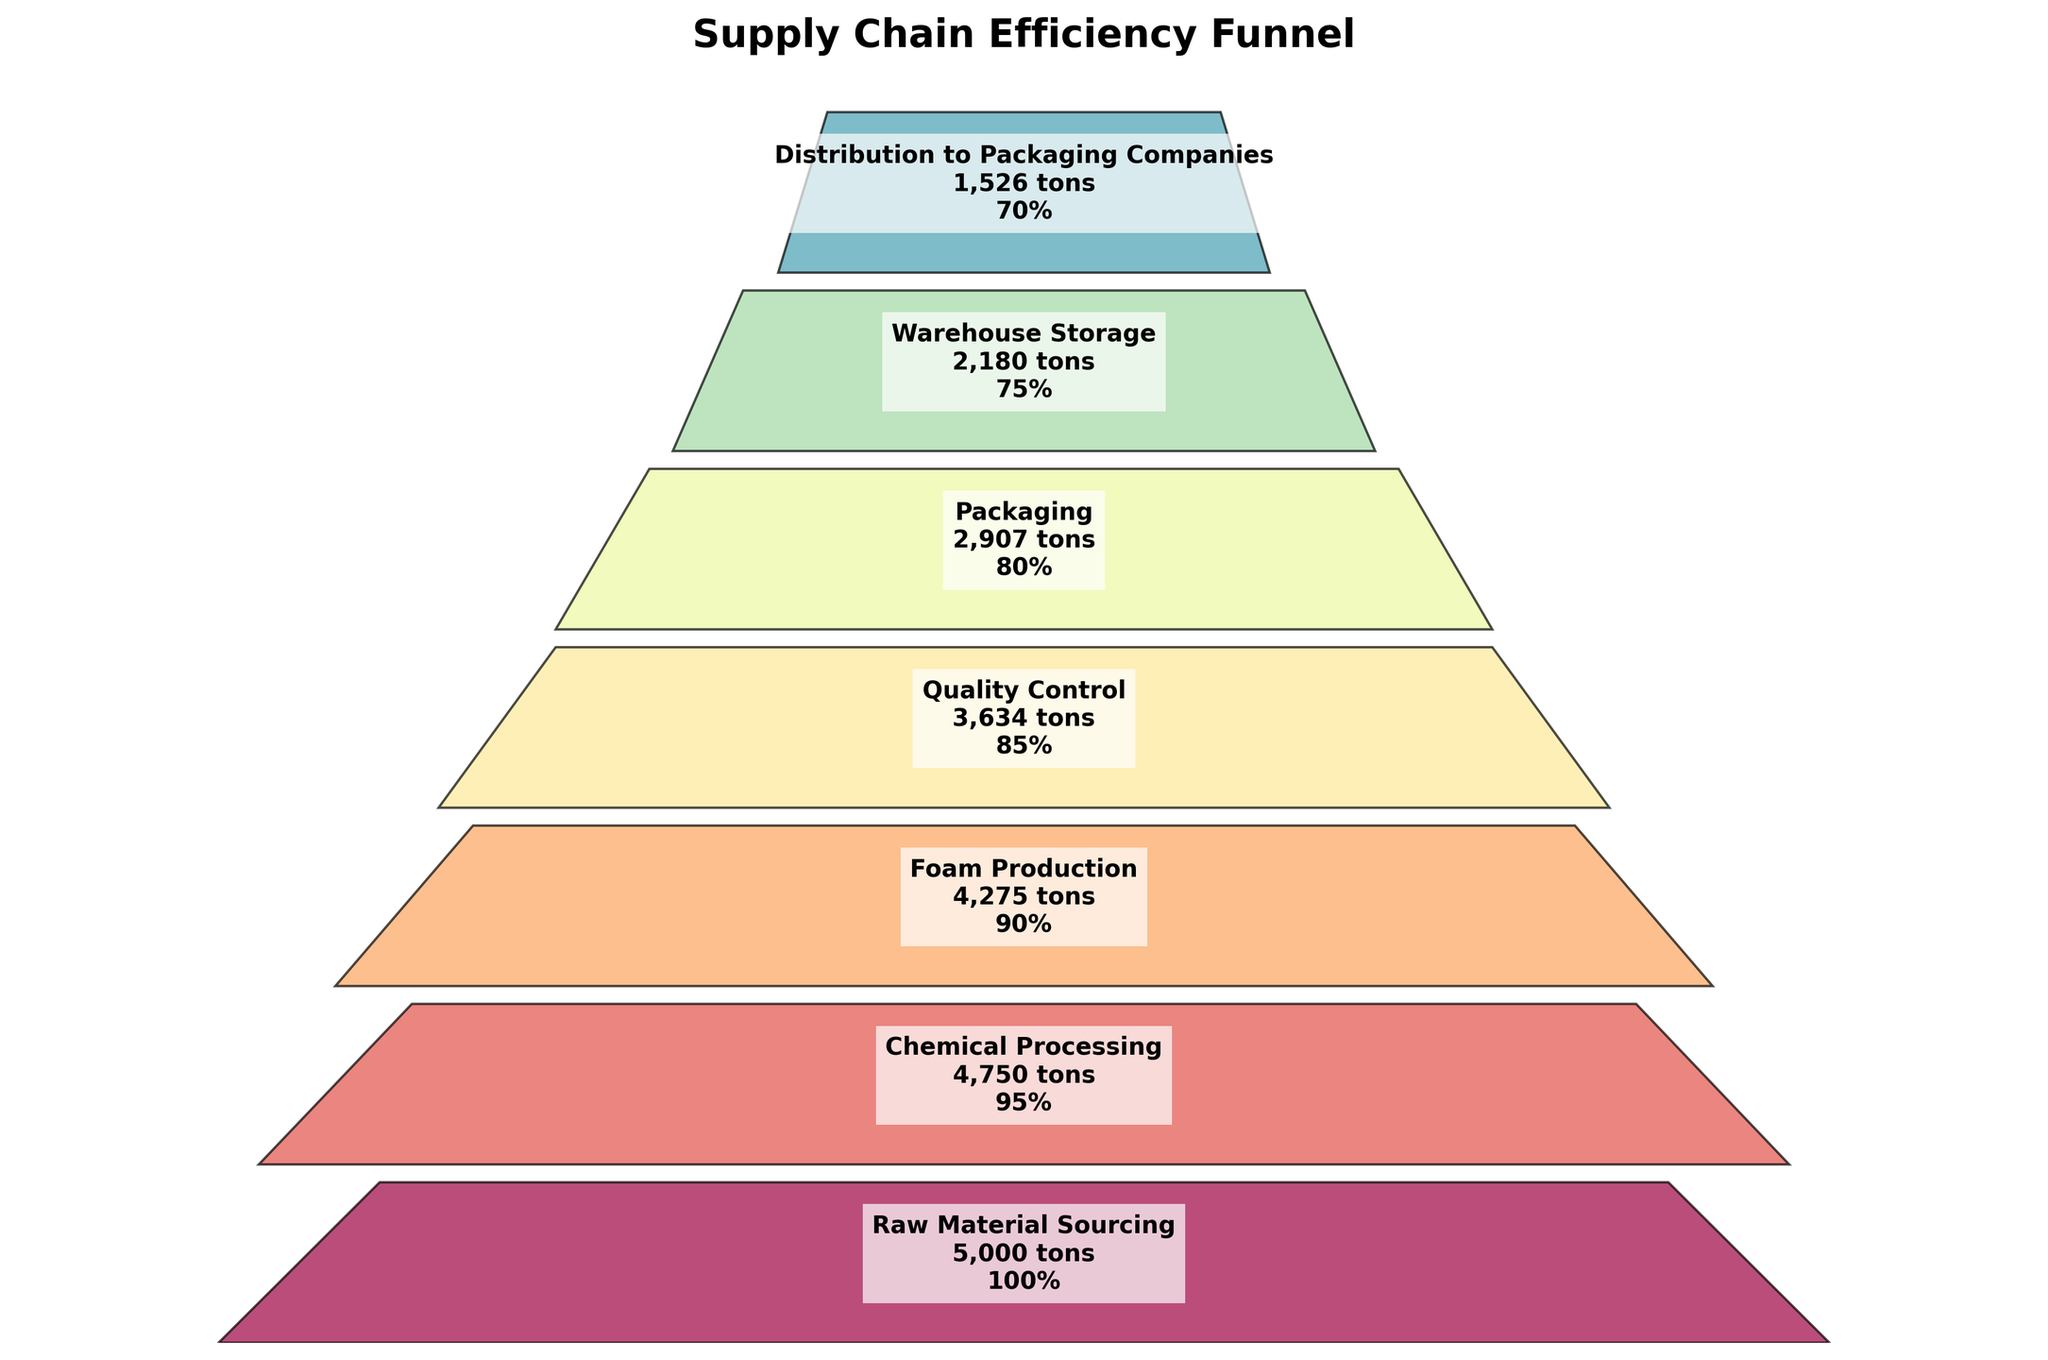How many stages are there in the supply chain? The stages are listed in the funnel chart, and each row represents a stage. Counting the rows gives the total number of stages.
Answer: 7 Which stage has the lowest volume of raw materials? By looking at the volumes listed beside each stage, the 'Distribution to Packaging Companies' stage has the lowest volume at 1526 metric tons.
Answer: Distribution to Packaging Companies What is the efficiency of the Packaging stage? The efficiency is shown next to each stage. For the Packaging stage, it is 80%.
Answer: 80% How much volume of raw materials is lost from Raw Material Sourcing to Distribution to Packaging Companies? Subtract the final volume (1526 metric tons) from the initial volume (5000 metric tons). 5000 - 1526 = 3474 metric tons.
Answer: 3474 metric tons Which stage shows the highest drop in efficiency compared to the previous stage? Compare the efficiency percentages between consecutive stages and find the largest difference. The drop from Quality Control to Packaging (85% to 80%) results in a 5% drop, which is the highest.
Answer: Quality Control to Packaging Calculate the average efficiency across all stages. Sum the efficiencies of all stages and then divide by the number of stages: (100 + 95 + 90 + 85 + 80 + 75 + 70) / 7 = 85%.
Answer: 85% Which stages lose more than 500 metric tons of raw materials compared to the previous stage? Look for stages where the difference in volume between consecutive stages is greater than 500 metric tons. Chemical Processing to Foam Production (4750 - 4275 = 475), Foam Production to Quality Control (4275 - 3634 = 641), and Packaging to Warehouse Storage (2907 - 2180 = 727) fit this criterion.
Answer: Foam Production to Quality Control, Packaging to Warehouse Storage How much raw material volume remains after Quality Control? The figure lists the volume for each stage. After Quality Control, 3634 metric tons remain.
Answer: 3634 metric tons Which stage has the highest initial efficiency? The highest efficiency is located at the first stage listed, which is Raw Material Sourcing with 100%.
Answer: Raw Material Sourcing Describe the trend of volume and efficiency through the stages. Both volume and efficiency decline as the stages progress from Raw Material Sourcing to Distribution to Packaging Companies.
Answer: Both volume and efficiency decline 